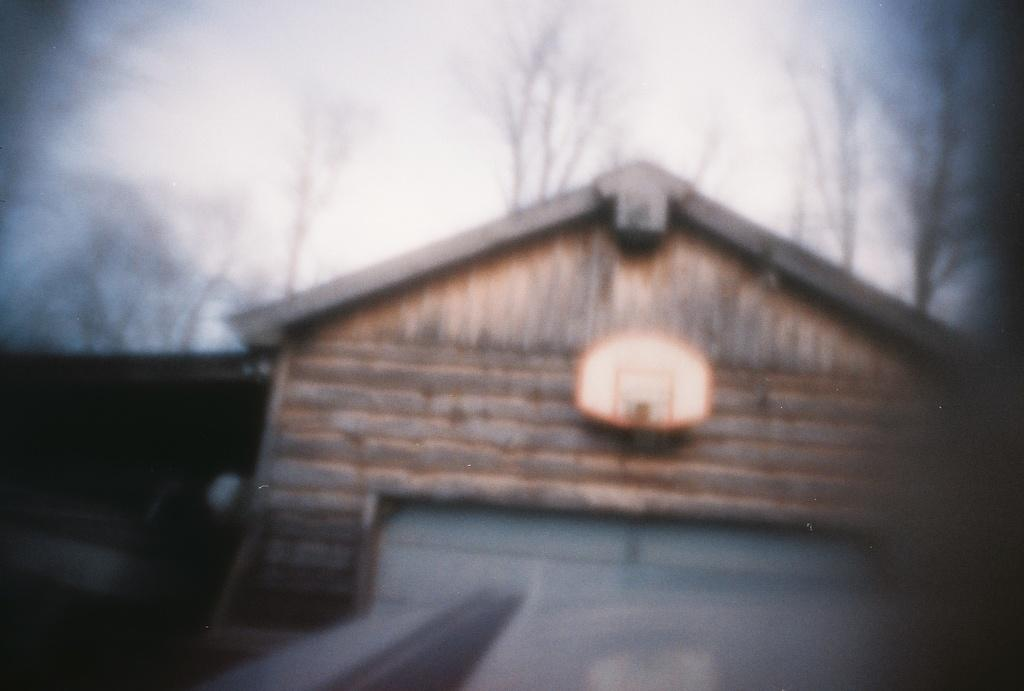What type of structure is visible in the image? There is a house in the image. What other natural elements can be seen in the image? There are trees in the image. What part of the natural environment is visible in the image? The sky is visible in the image. Where is the airport located in the image? There is no airport present in the image; it features a house, trees, and the sky. Can you tell me how many geese are flying in the image? There are no geese present in the image. 